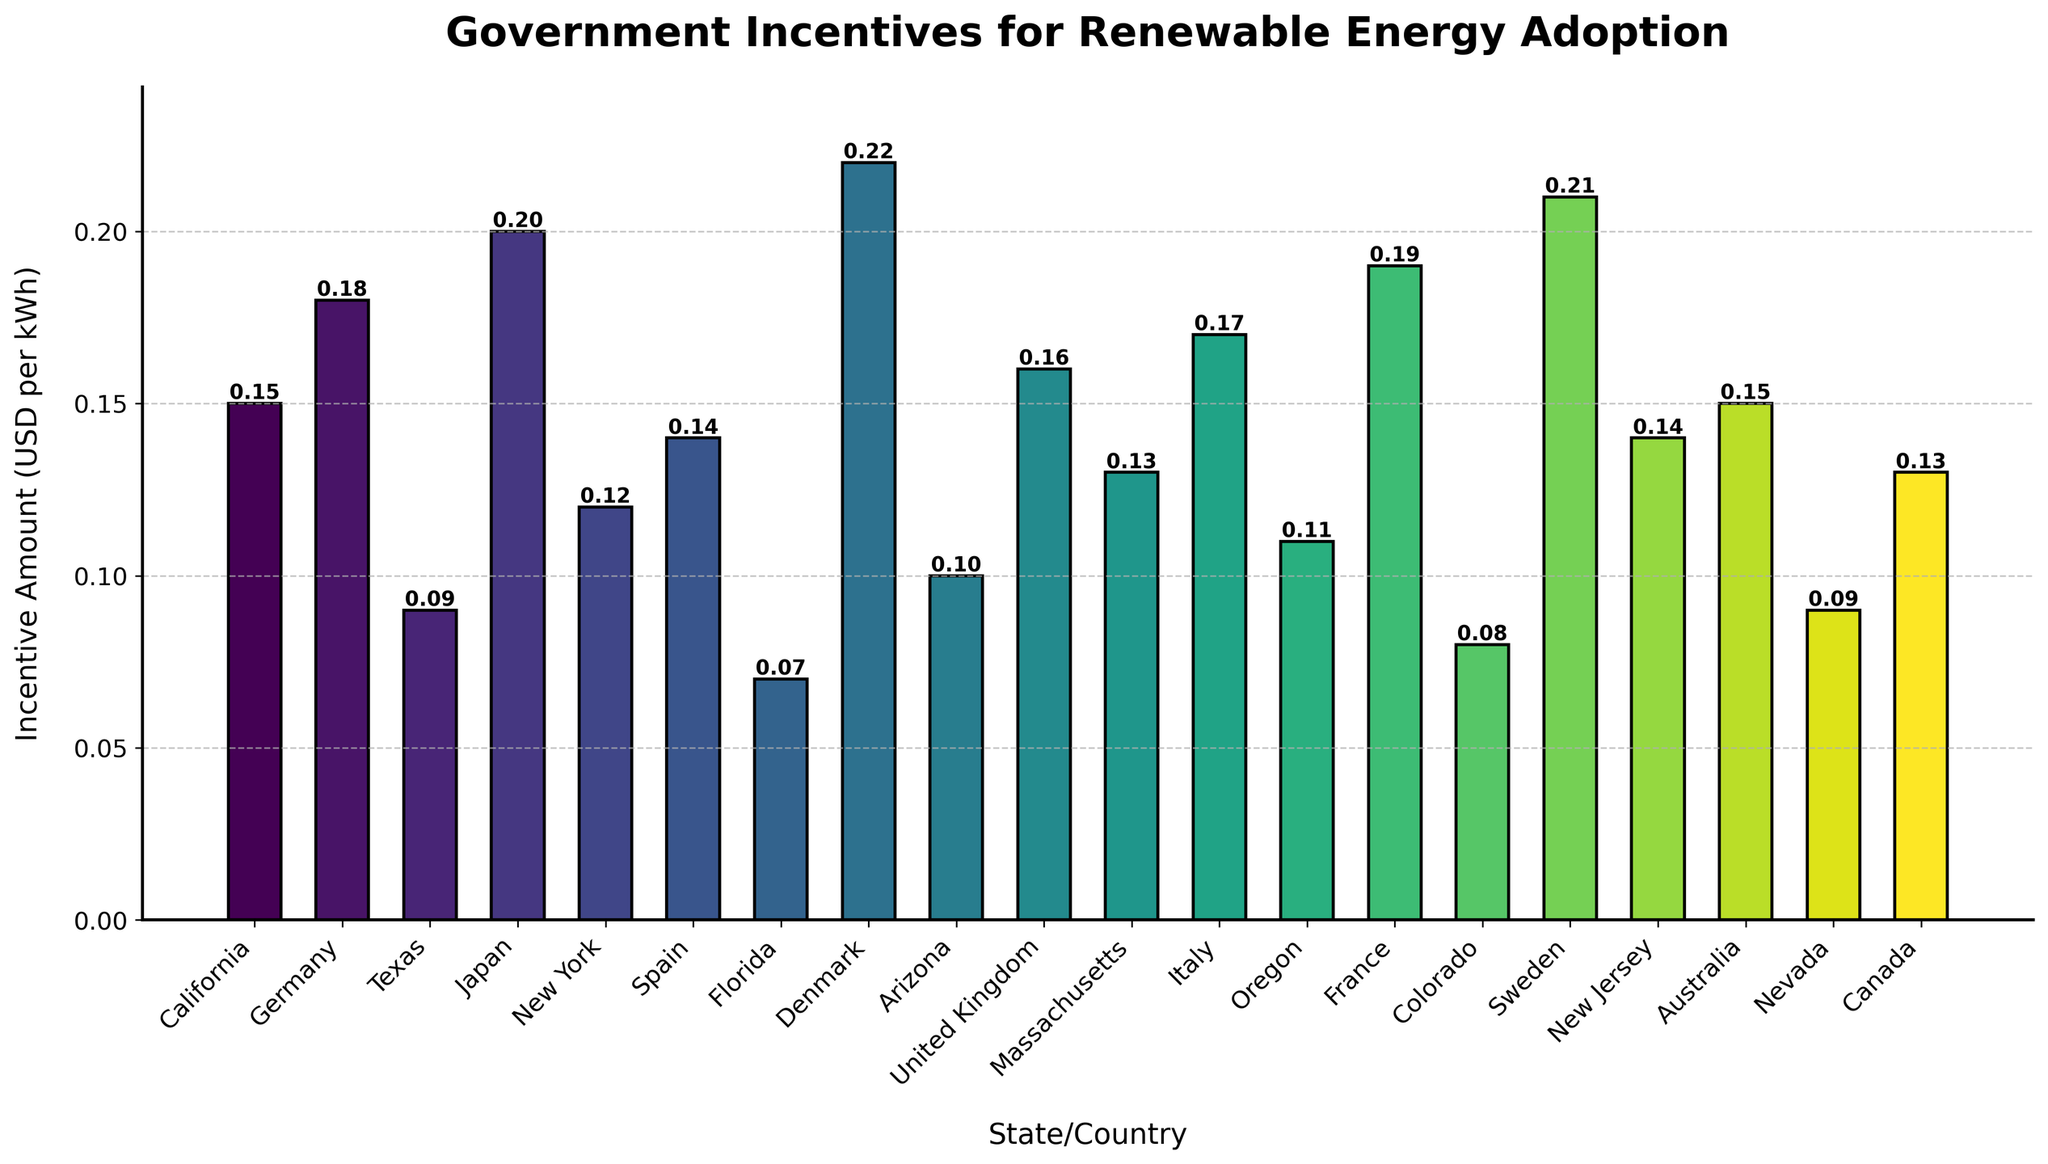Which state/country offers the highest government incentive for renewable energy adoption? The highest bar represents the state/country with the highest incentive amount. According to the figure, Denmark offers the highest incentive, which is 0.22 USD per kWh.
Answer: Denmark Which two states/countries offer the lowest government incentives for renewable energy adoption? The two smallest bars correspond to Florida and Colorado, which offer the lowest incentives of 0.07 and 0.08 USD per kWh, respectively.
Answer: Florida and Colorado How much more is the incentive amount in France compared to Texas? The incentive amount in France is 0.19 USD per kWh, and in Texas, it is 0.09 USD per kWh. The difference is 0.19 - 0.09 = 0.10 USD per kWh.
Answer: 0.10 USD per kWh What is the average incentive amount provided by California, Germany, and Japan? Add the incentive amounts for California (0.15), Germany (0.18), and Japan (0.20), and then divide by the number of states/countries (3). (0.15 + 0.18 + 0.20) / 3 = 0.18 USD per kWh.
Answer: 0.18 USD per kWh Identify the bar representing New York. Is it taller or shorter than the average incentive amount across all states/countries? First, calculate the average incentive amount for all the states/countries by summing up all the incentive amounts and dividing by the number of states/countries. The total sum is 2.40, and there are 20 states/countries, so the average is 2.40 / 20 = 0.12 USD per kWh. The bar for New York represents an incentive amount of 0.12 USD per kWh, which is equal to the overall average.
Answer: Equal to the average Which states/countries provide incentives higher than 0.15 USD per kWh? Identify bars representing incentive amounts greater than 0.15 USD per kWh. They are for Germany (0.18), Japan (0.20), Denmark (0.22), United Kingdom (0.16), Italy (0.17), France (0.19), and Sweden (0.21).
Answer: Germany, Japan, Denmark, United Kingdom, Italy, France, and Sweden What is the combined incentive amount for Massachusetts and New Jersey? Add the incentive amounts for Massachusetts (0.13) and New Jersey (0.14). 0.13 + 0.14 = 0.27 USD per kWh.
Answer: 0.27 USD per kWh How does the incentive amount in Oregon compare to Australia? The incentive amount is 0.11 USD per kWh in Oregon and 0.15 USD per kWh in Australia. Therefore, Oregon's incentive is lower than Australia's by 0.15 - 0.11 = 0.04 USD per kWh.
Answer: 0.04 USD per kWh lower Which country provides the incentive closest to the median value of the dataset? To find the median value, sort all incentive amounts and find the middle value. Sorted values: 0.07, 0.08, 0.09, 0.09, 0.10, 0.11, 0.12, 0.13, 0.13, 0.14, 0.14, 0.15, 0.15, 0.16, 0.17, 0.18, 0.19, 0.20, 0.21, 0.22. The middle values are the 10th and 11th: 0.14 and 0.14. The median is (0.14 + 0.14) / 2 = 0.14. Countries with 0.14 USD per kWh are Spain and New Jersey.
Answer: Spain and New Jersey 